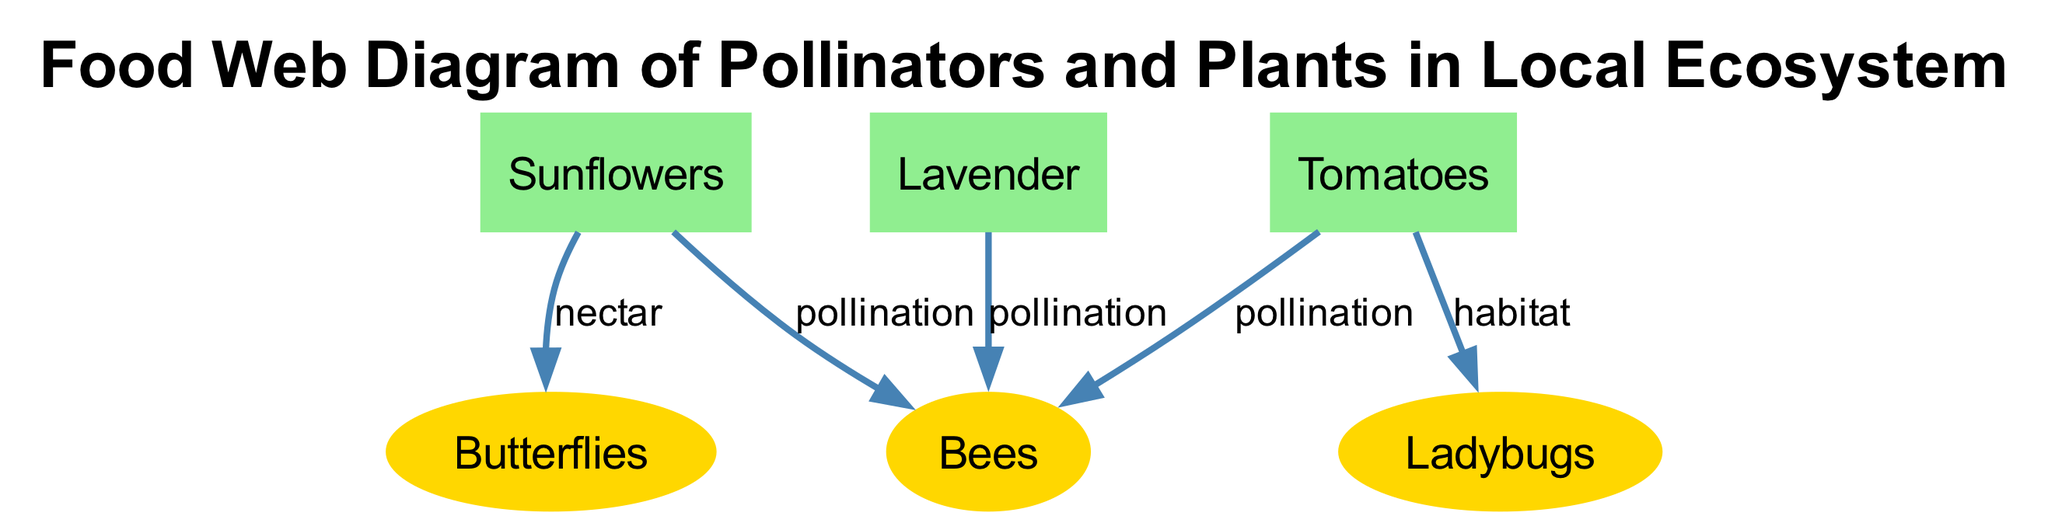What are the pollinators listed in the diagram? The diagram includes three pollinators: bees, butterflies, and ladybugs. Each of these pollinators is represented as a separate node connected by edges to the plants, showing their roles in pollination or habitat.
Answer: bees, butterflies, ladybugs How many plants are connected to bees in the diagram? The diagram shows three plants connected to the bees through pollination: sunflowers, lavender, and tomatoes. This can be verified by counting the edges that originate from these plants towards the bees.
Answer: 3 What type of relationship is shown between sunflowers and butterflies? The diagram indicates a "nectar" relationship between sunflowers and butterflies, as represented by an edge connecting these two nodes. This relationship illustrates that butterflies are attracted to sunflowers for nectar.
Answer: nectar What effect do ladybugs have on pest insects according to the diagram? Ladybugs are shown to control pest insects, as indicated by the directed edge from ladybugs to pest insects labeled "control pests." This underlines their role as beneficial insects in maintaining ecosystem balance.
Answer: control pests Which plant is the only one that provides habitat for ladybugs? The tomatoes plant is identified in the diagram as providing habitat for ladybugs. This is discerned by the edge connecting tomatoes to ladybugs labeled "habitat," which explicitly states this relationship.
Answer: tomatoes What is the main function of the "composting" node in the nutrient cycle? The "composting" node is crucial as it adds nutrients back to the soil. This is evidenced by the edge connecting composting to soil labeled "adds nutrients," highlighting its role in the nutrient cycle within organic farming.
Answer: adds nutrients How do chemical pesticides affect beneficial insects? The diagram shows that chemical pesticides have a harmful impact on beneficial insects, as denoted by the edge labeled "harmful" that connects pesticides to beneficial insects, demonstrating their negative effect.
Answer: harmful What kind of pesticides do ladybugs help control? Ladybugs are indicated to help control pest insects. This is depicted in the diagram by the edge linking ladybugs to pest insects labeled "control pests," showcasing their role in pest management.
Answer: pest insects Which method improves plant health according to the diagram? Both ladybugs and neem oil are methods that improve plant health, as illustrated by edges linking them to plant health, with the edges labeled “improves,” confirming their beneficial contributions.
Answer: ladybugs, neem oil 